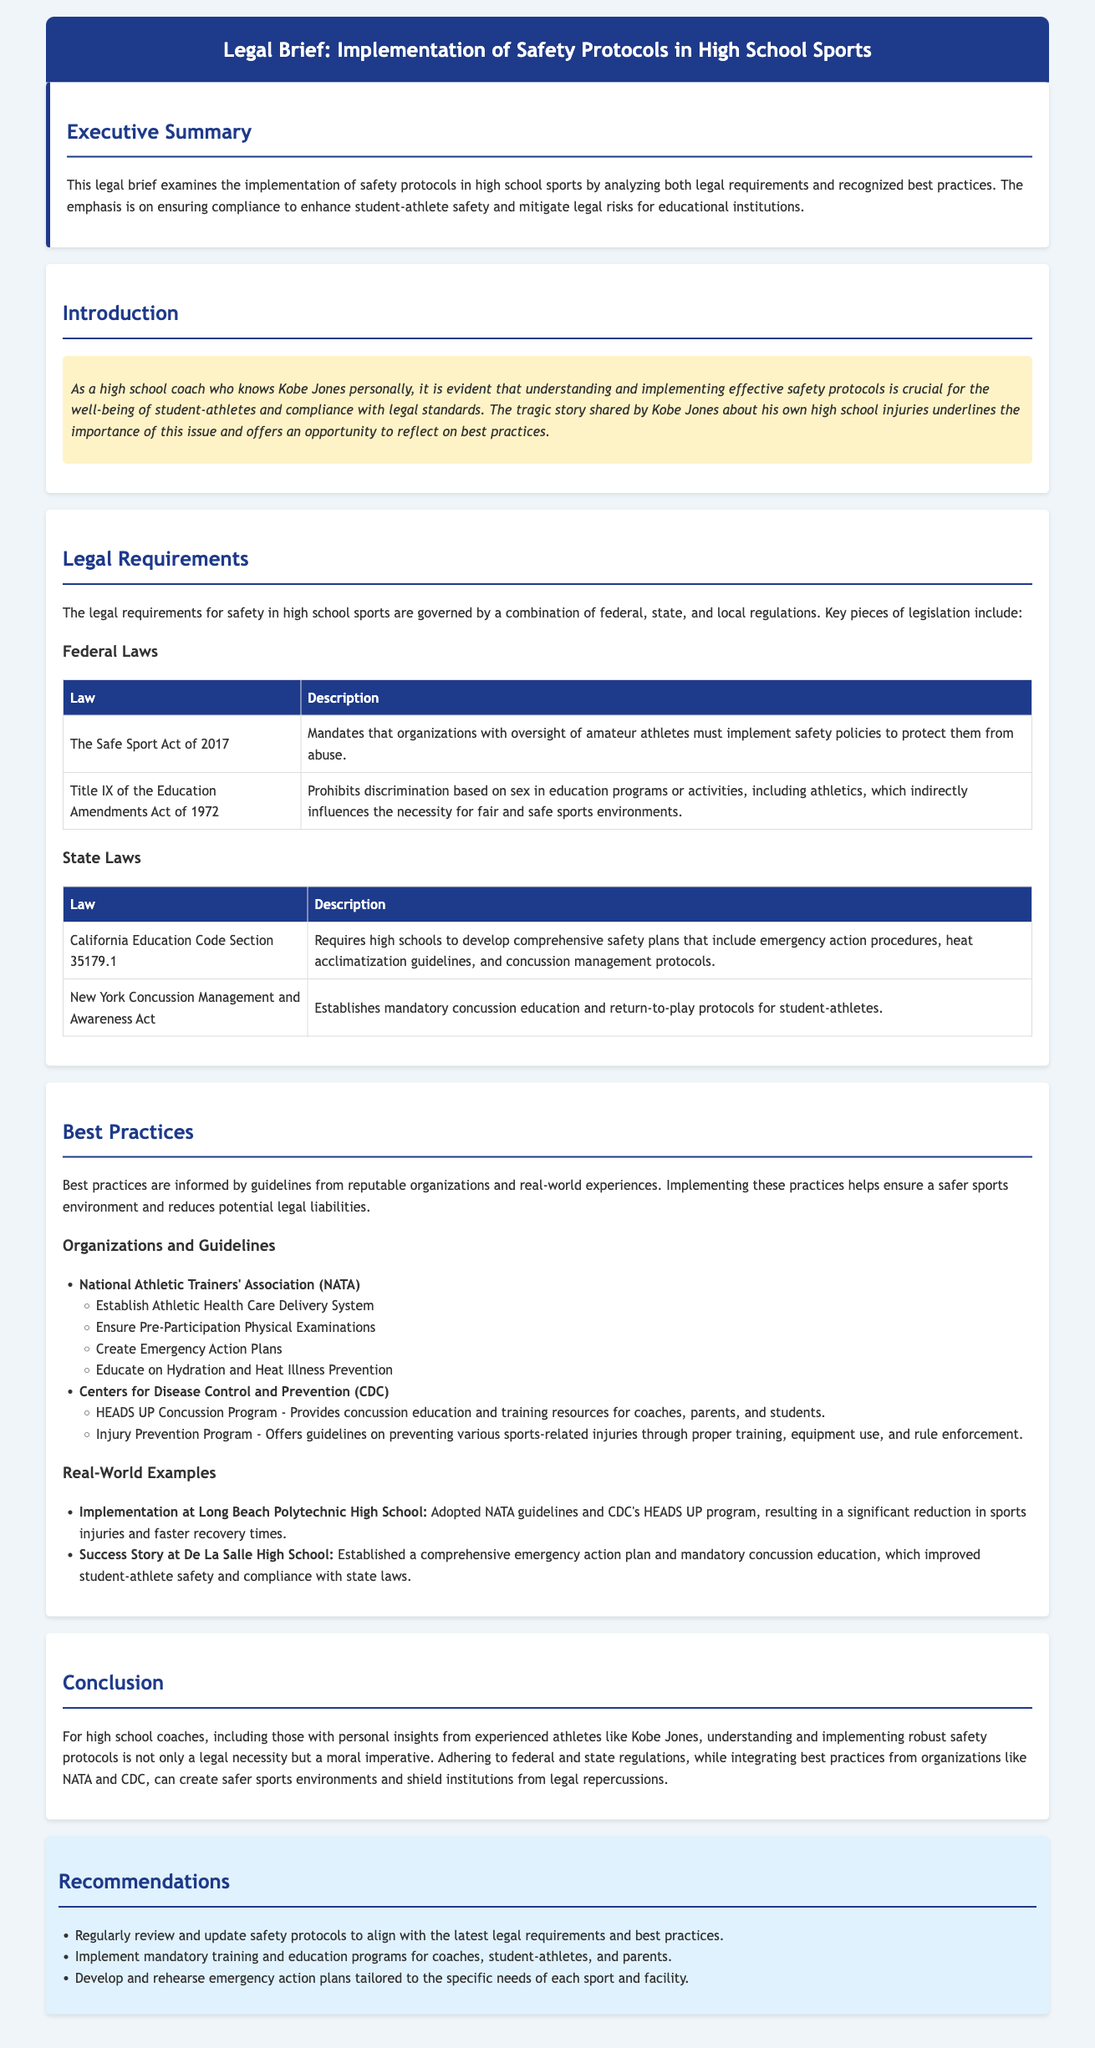What is the title of the legal brief? The title is provided in the header of the document.
Answer: Implementation of Safety Protocols in High School Sports What does the Safe Sport Act of 2017 mandate? The description of this act is given under federal laws.
Answer: Implement safety policies to protect athletes from abuse Which state law requires high schools to develop comprehensive safety plans? This information is found in the legal requirements section under state laws.
Answer: California Education Code Section 35179.1 Name a best practice recommended by the National Athletic Trainers' Association (NATA). Recommendations are listed under best practices, specifically from NATA.
Answer: Ensure Pre-Participation Physical Examinations What program does the CDC offer for concussion education? The specific program is mentioned within the best practices section.
Answer: HEADS UP Concussion Program What is the focus of the executive summary? The focus is summarized in the executive summary section of the document.
Answer: Implementation of safety protocols in high school sports What emotional story is referenced in relation to safety protocols? The introduction highlights this personal story context.
Answer: Kobe Jones’s own high school injuries What type of plan is recommended to be developed and rehearsed? The specific type of plan is mentioned under recommendations.
Answer: Emergency action plans 